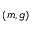<formula> <loc_0><loc_0><loc_500><loc_500>( m , g )</formula> 